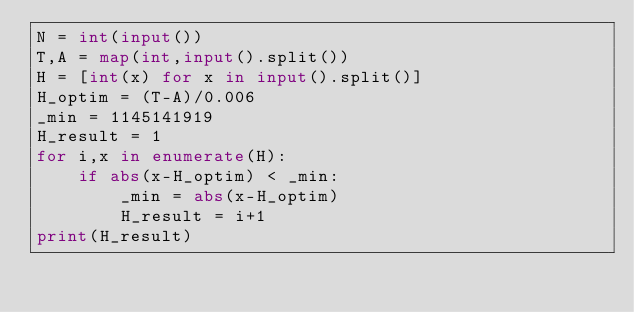Convert code to text. <code><loc_0><loc_0><loc_500><loc_500><_Python_>N = int(input())
T,A = map(int,input().split())
H = [int(x) for x in input().split()]
H_optim = (T-A)/0.006
_min = 1145141919
H_result = 1
for i,x in enumerate(H):
    if abs(x-H_optim) < _min:
        _min = abs(x-H_optim)
        H_result = i+1
print(H_result)</code> 